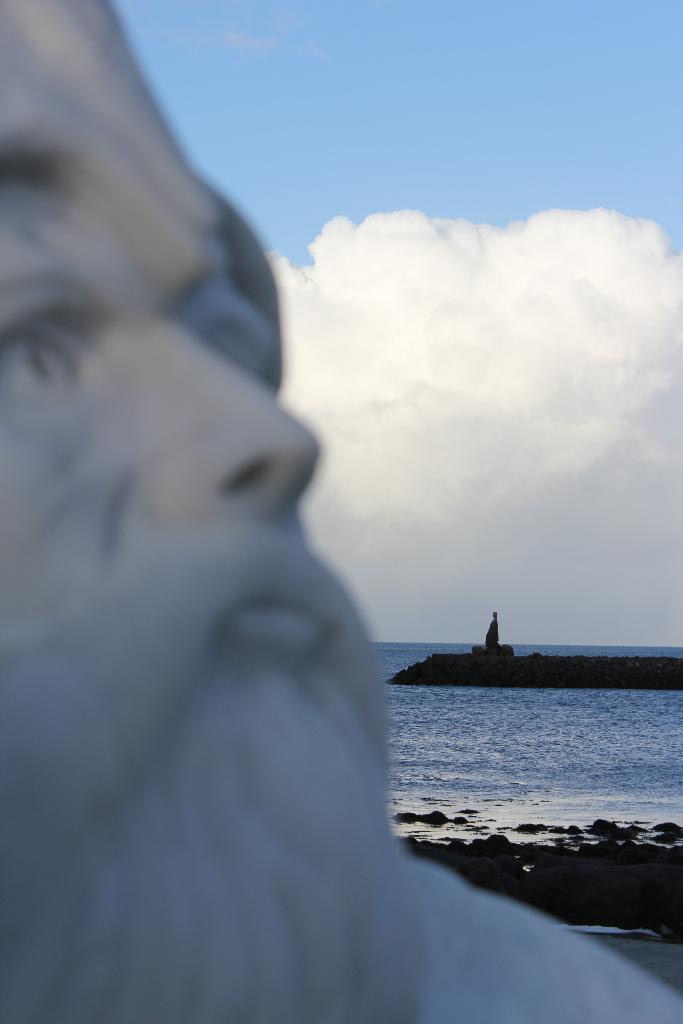What is the main subject of the image? There is a statue in the image. What can be seen in the background of the image? There is water visible in the image. What is the color of the sky in the image? The sky is blue in color. Can you describe the object on the left side of the image? Unfortunately, the provided facts do not give any information about the object on the left side of the image. What type of scent is associated with the statue in the image? There is no information about a scent in the image, as it is a visual medium. 